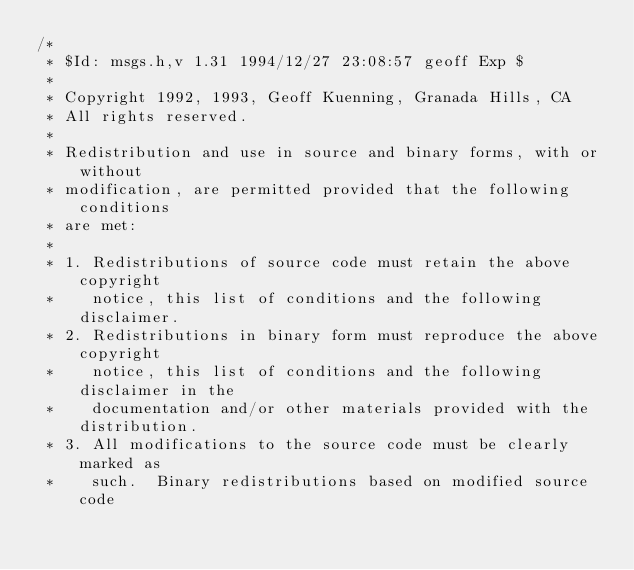Convert code to text. <code><loc_0><loc_0><loc_500><loc_500><_C_>/*
 * $Id: msgs.h,v 1.31 1994/12/27 23:08:57 geoff Exp $
 *
 * Copyright 1992, 1993, Geoff Kuenning, Granada Hills, CA
 * All rights reserved.
 *
 * Redistribution and use in source and binary forms, with or without
 * modification, are permitted provided that the following conditions
 * are met:
 *
 * 1. Redistributions of source code must retain the above copyright
 *    notice, this list of conditions and the following disclaimer.
 * 2. Redistributions in binary form must reproduce the above copyright
 *    notice, this list of conditions and the following disclaimer in the
 *    documentation and/or other materials provided with the distribution.
 * 3. All modifications to the source code must be clearly marked as
 *    such.  Binary redistributions based on modified source code</code> 